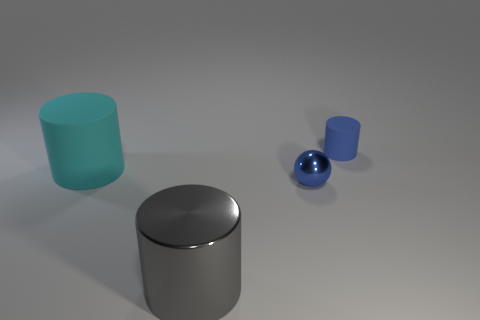Subtract all metal cylinders. How many cylinders are left? 2 Add 2 large green matte balls. How many objects exist? 6 Subtract all yellow cylinders. Subtract all brown spheres. How many cylinders are left? 3 Add 4 small gray rubber objects. How many small gray rubber objects exist? 4 Subtract 0 blue cubes. How many objects are left? 4 Subtract all balls. How many objects are left? 3 Subtract all large cylinders. Subtract all cyan balls. How many objects are left? 2 Add 2 big cyan objects. How many big cyan objects are left? 3 